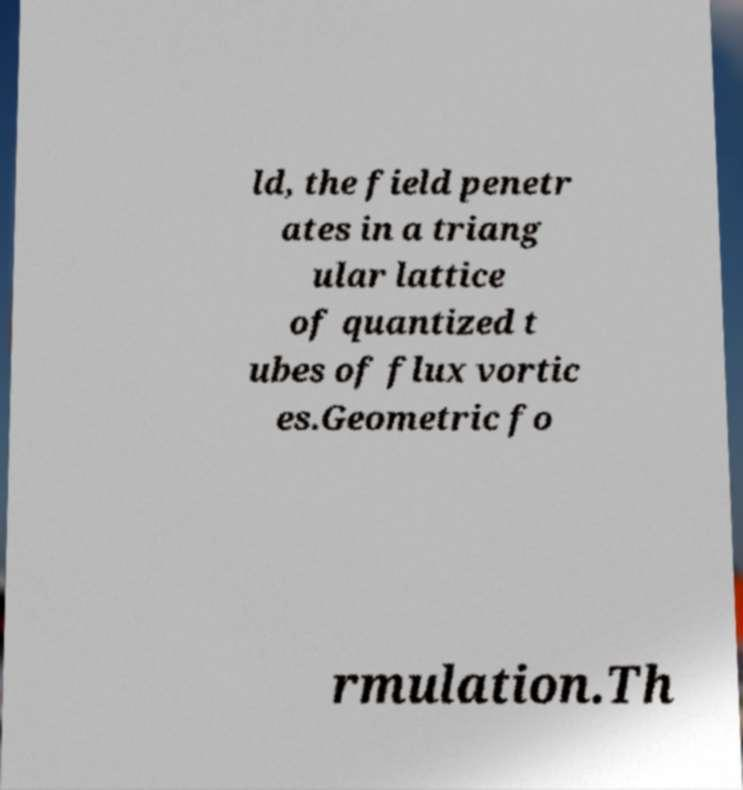Please read and relay the text visible in this image. What does it say? ld, the field penetr ates in a triang ular lattice of quantized t ubes of flux vortic es.Geometric fo rmulation.Th 